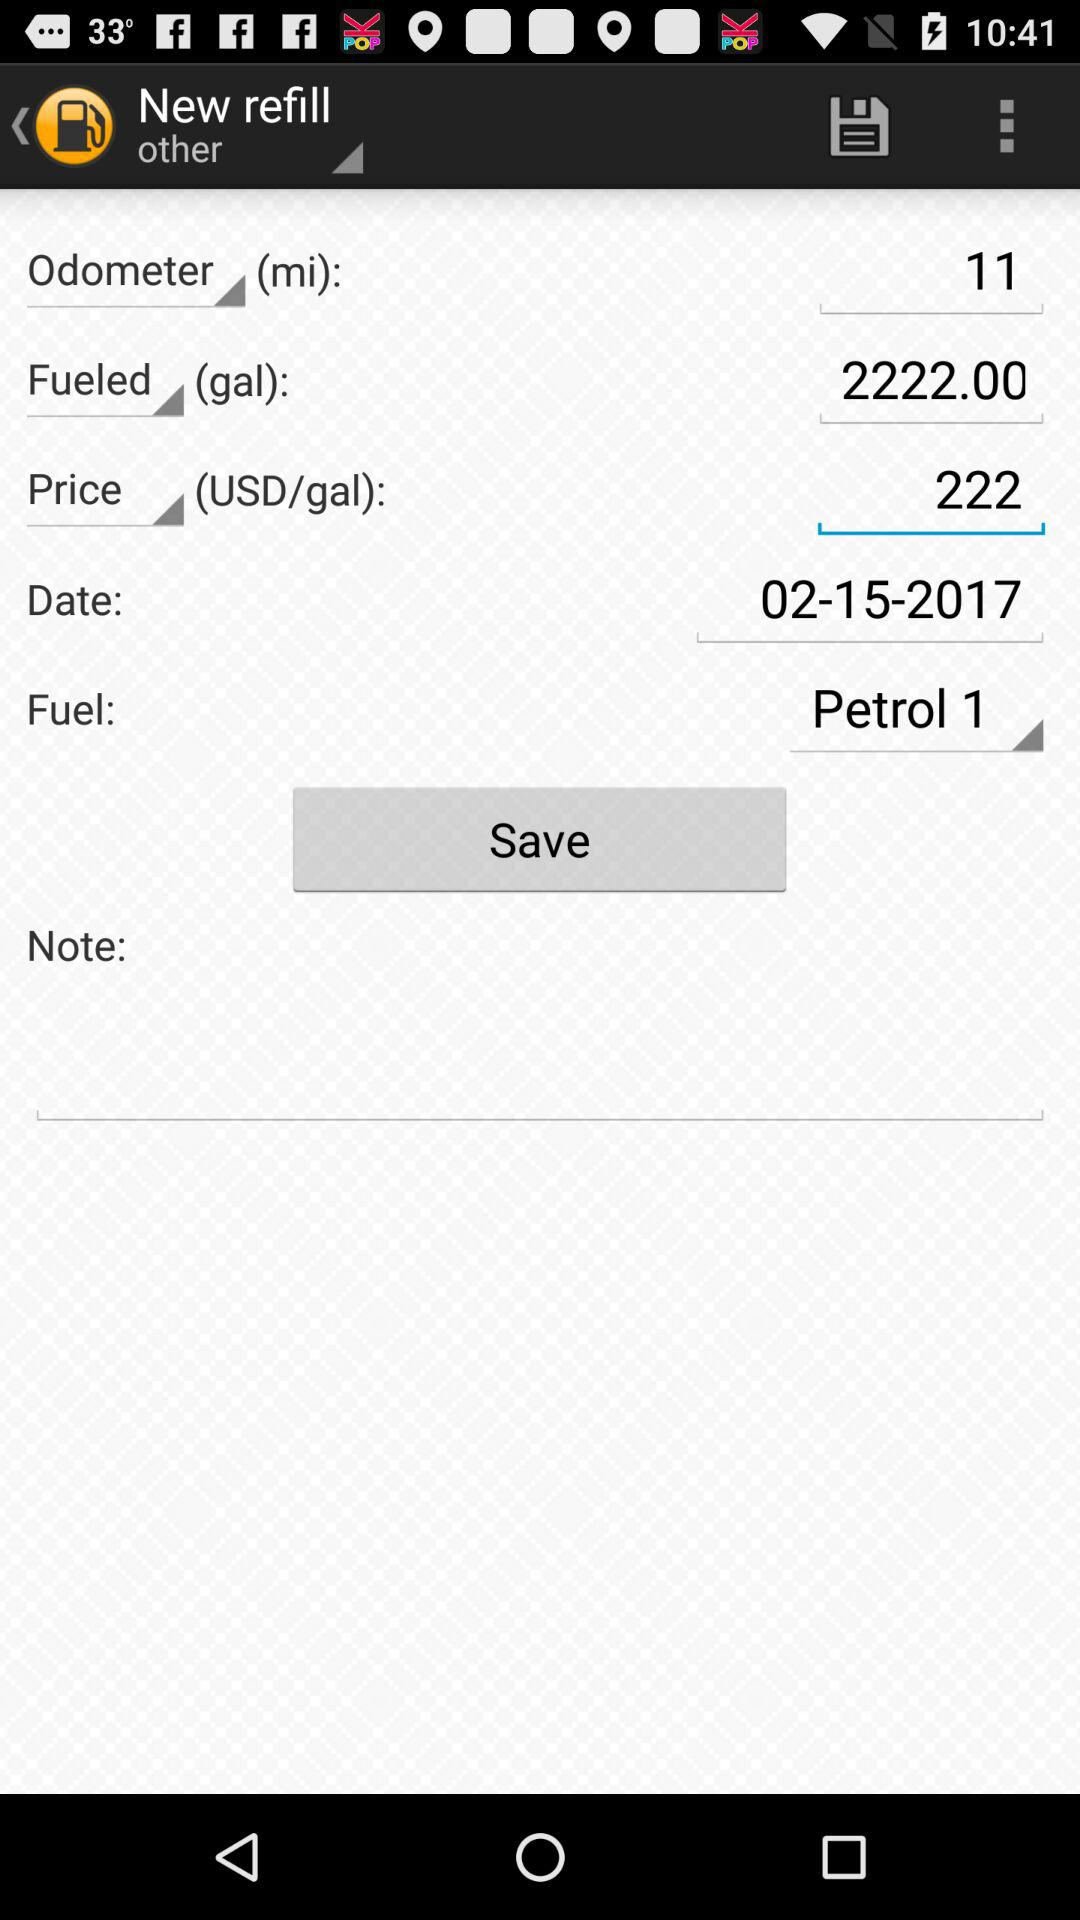What is the date of this fill-up?
Answer the question using a single word or phrase. 02-15-2017 